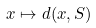<formula> <loc_0><loc_0><loc_500><loc_500>x \mapsto d ( x , S )</formula> 